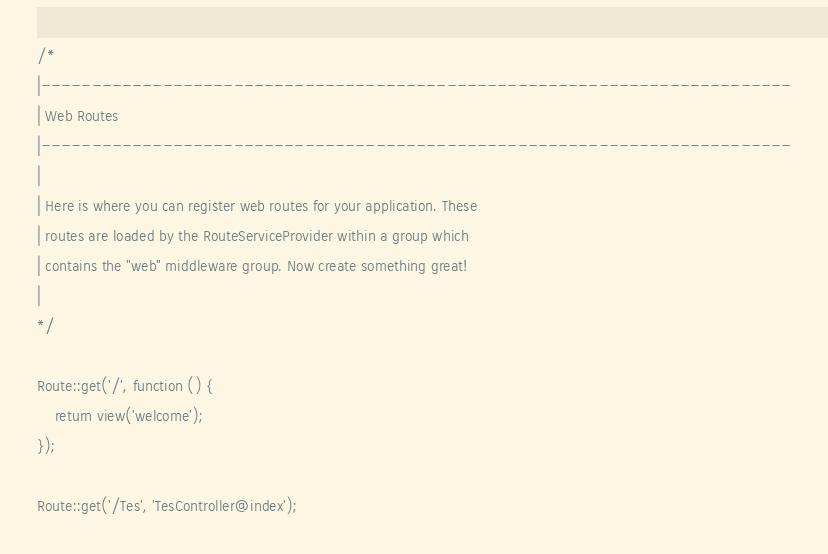<code> <loc_0><loc_0><loc_500><loc_500><_PHP_>
/*
|--------------------------------------------------------------------------
| Web Routes
|--------------------------------------------------------------------------
|
| Here is where you can register web routes for your application. These
| routes are loaded by the RouteServiceProvider within a group which
| contains the "web" middleware group. Now create something great!
|
*/

Route::get('/', function () {
    return view('welcome');
});

Route::get('/Tes', 'TesController@index');
</code> 